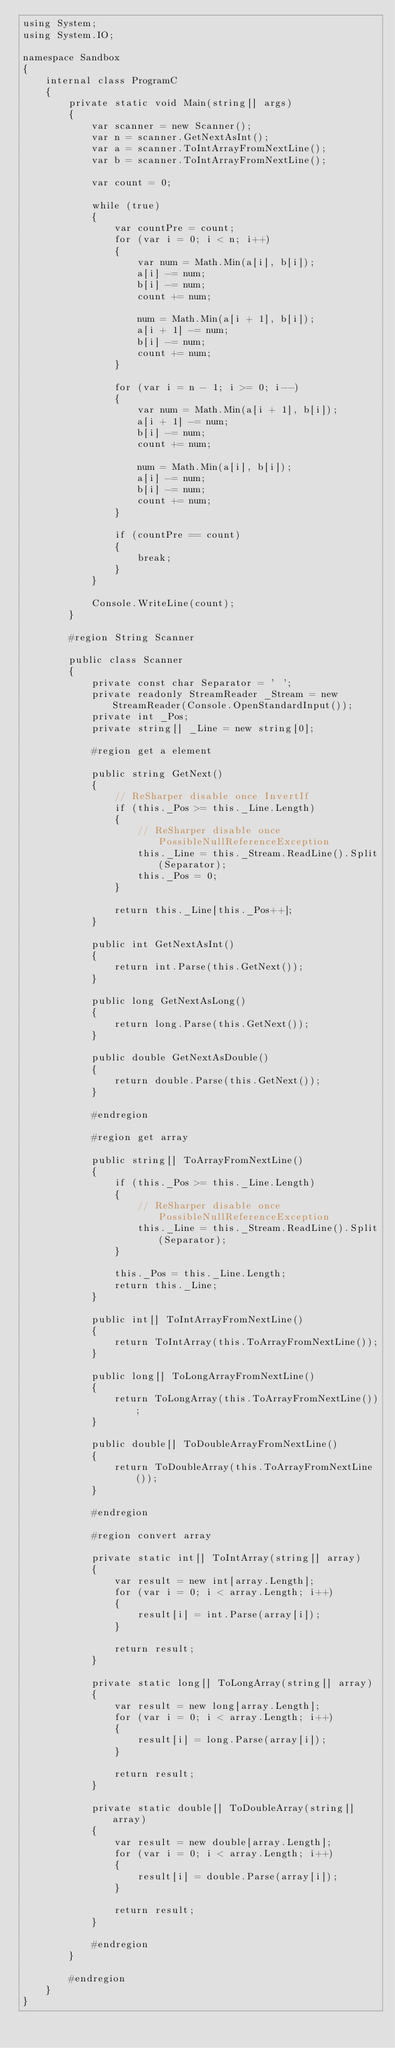<code> <loc_0><loc_0><loc_500><loc_500><_C#_>using System;
using System.IO;

namespace Sandbox
{
    internal class ProgramC
    {
        private static void Main(string[] args)
        {
            var scanner = new Scanner();
            var n = scanner.GetNextAsInt();
            var a = scanner.ToIntArrayFromNextLine();
            var b = scanner.ToIntArrayFromNextLine();

            var count = 0;

            while (true)
            {
                var countPre = count;
                for (var i = 0; i < n; i++)
                {
                    var num = Math.Min(a[i], b[i]);
                    a[i] -= num;
                    b[i] -= num;
                    count += num;

                    num = Math.Min(a[i + 1], b[i]);
                    a[i + 1] -= num;
                    b[i] -= num;
                    count += num;
                }

                for (var i = n - 1; i >= 0; i--)
                {
                    var num = Math.Min(a[i + 1], b[i]);
                    a[i + 1] -= num;
                    b[i] -= num;
                    count += num;

                    num = Math.Min(a[i], b[i]);
                    a[i] -= num;
                    b[i] -= num;
                    count += num;
                }

                if (countPre == count)
                {
                    break;
                }
            }

            Console.WriteLine(count);
        }

        #region String Scanner

        public class Scanner
        {
            private const char Separator = ' ';
            private readonly StreamReader _Stream = new StreamReader(Console.OpenStandardInput());
            private int _Pos;
            private string[] _Line = new string[0];

            #region get a element

            public string GetNext()
            {
                // ReSharper disable once InvertIf
                if (this._Pos >= this._Line.Length)
                {
                    // ReSharper disable once PossibleNullReferenceException
                    this._Line = this._Stream.ReadLine().Split(Separator);
                    this._Pos = 0;
                }

                return this._Line[this._Pos++];
            }

            public int GetNextAsInt()
            {
                return int.Parse(this.GetNext());
            }

            public long GetNextAsLong()
            {
                return long.Parse(this.GetNext());
            }

            public double GetNextAsDouble()
            {
                return double.Parse(this.GetNext());
            }

            #endregion

            #region get array

            public string[] ToArrayFromNextLine()
            {
                if (this._Pos >= this._Line.Length)
                {
                    // ReSharper disable once PossibleNullReferenceException
                    this._Line = this._Stream.ReadLine().Split(Separator);
                }

                this._Pos = this._Line.Length;
                return this._Line;
            }

            public int[] ToIntArrayFromNextLine()
            {
                return ToIntArray(this.ToArrayFromNextLine());
            }

            public long[] ToLongArrayFromNextLine()
            {
                return ToLongArray(this.ToArrayFromNextLine());
            }

            public double[] ToDoubleArrayFromNextLine()
            {
                return ToDoubleArray(this.ToArrayFromNextLine());
            }

            #endregion

            #region convert array

            private static int[] ToIntArray(string[] array)
            {
                var result = new int[array.Length];
                for (var i = 0; i < array.Length; i++)
                {
                    result[i] = int.Parse(array[i]);
                }

                return result;
            }

            private static long[] ToLongArray(string[] array)
            {
                var result = new long[array.Length];
                for (var i = 0; i < array.Length; i++)
                {
                    result[i] = long.Parse(array[i]);
                }

                return result;
            }

            private static double[] ToDoubleArray(string[] array)
            {
                var result = new double[array.Length];
                for (var i = 0; i < array.Length; i++)
                {
                    result[i] = double.Parse(array[i]);
                }

                return result;
            }

            #endregion
        }

        #endregion
    }
}
</code> 